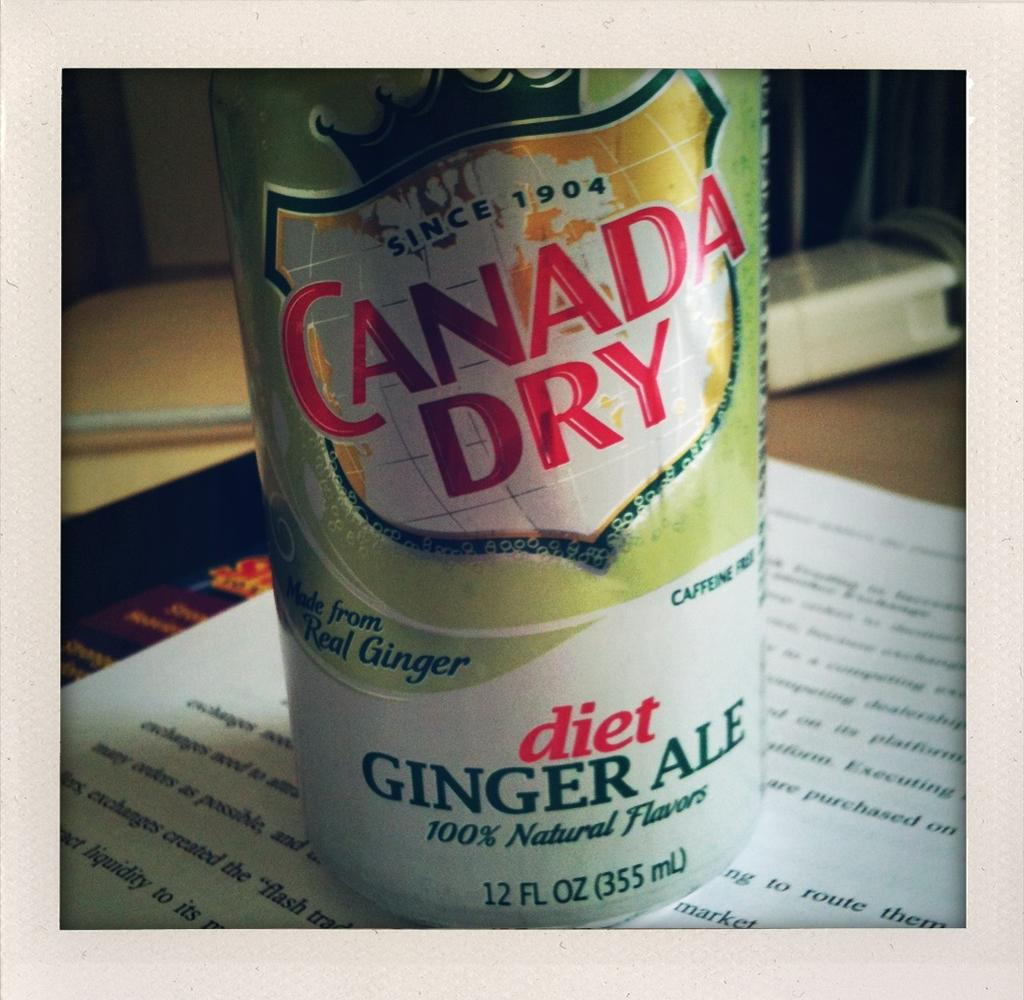<image>
Provide a brief description of the given image. A can of diet Ginger Ale from Canada Dry on top of an open book. 